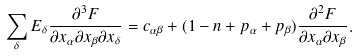Convert formula to latex. <formula><loc_0><loc_0><loc_500><loc_500>\sum _ { \delta } E _ { \delta } \frac { \partial ^ { 3 } F } { \partial x _ { \alpha } \partial x _ { \beta } \partial x _ { \delta } } = c _ { \alpha \beta } + ( 1 - n + p _ { \alpha } + p _ { \beta } ) \frac { \partial ^ { 2 } F } { \partial x _ { \alpha } \partial x _ { \beta } } .</formula> 